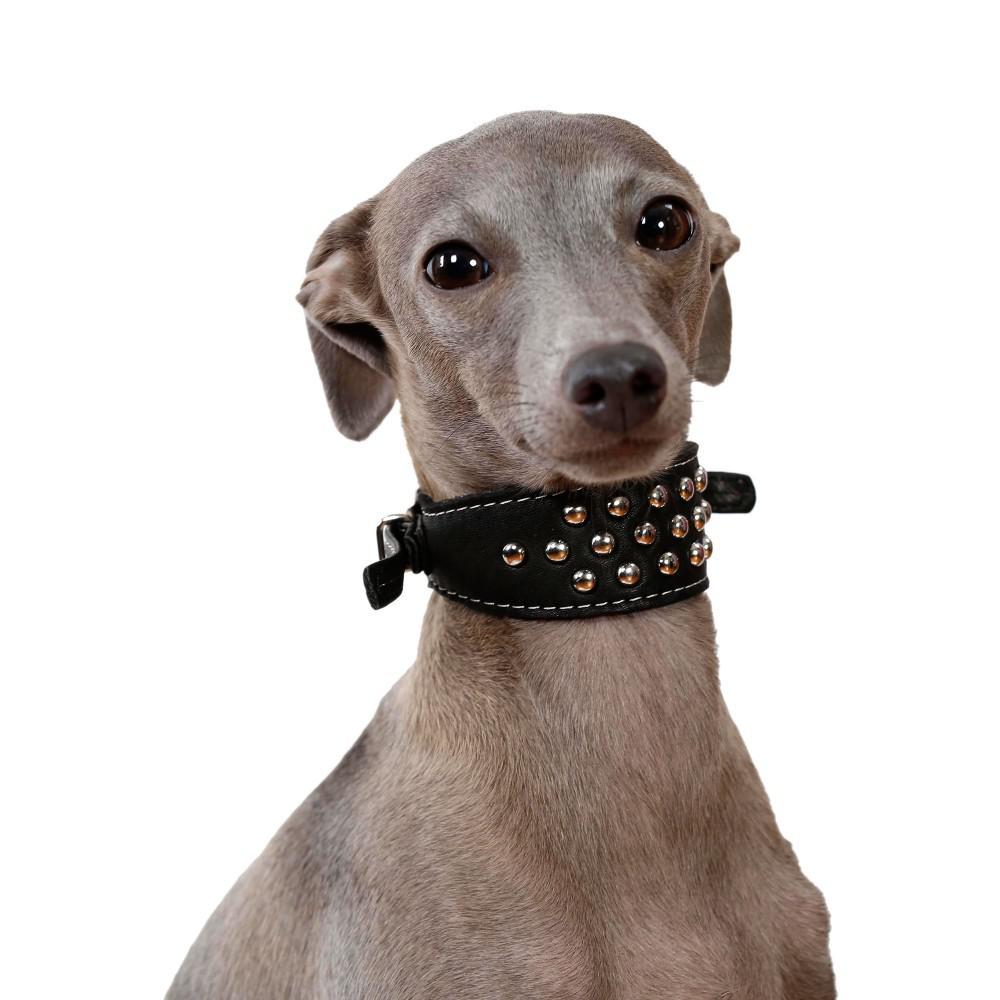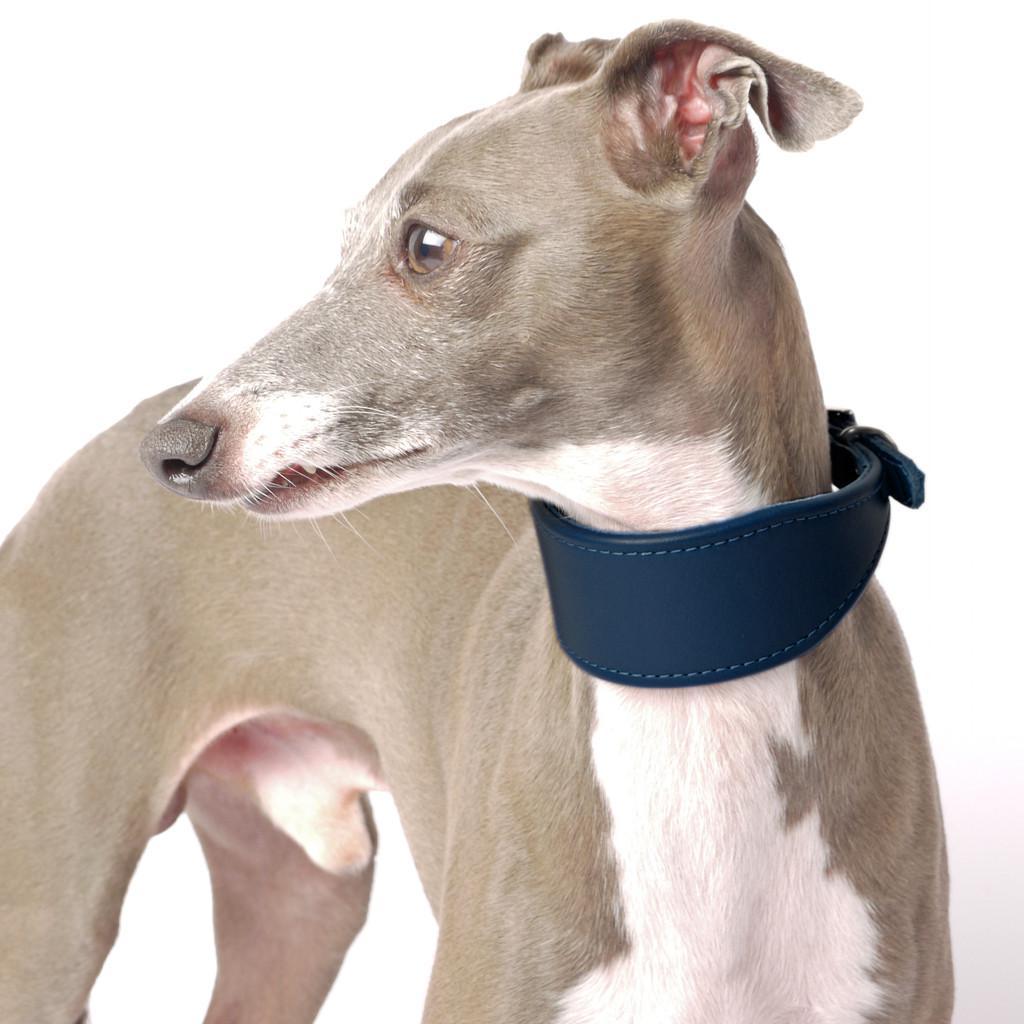The first image is the image on the left, the second image is the image on the right. Evaluate the accuracy of this statement regarding the images: "In total, more than one dog is wearing something around its neck.". Is it true? Answer yes or no. Yes. The first image is the image on the left, the second image is the image on the right. Given the left and right images, does the statement "At least one of the dogs is wearing some type of material." hold true? Answer yes or no. Yes. 